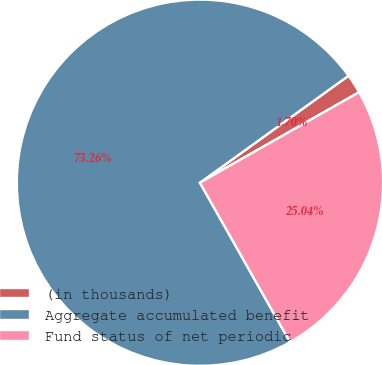Convert chart to OTSL. <chart><loc_0><loc_0><loc_500><loc_500><pie_chart><fcel>(in thousands)<fcel>Aggregate accumulated benefit<fcel>Fund status of net periodic<nl><fcel>1.7%<fcel>73.26%<fcel>25.04%<nl></chart> 